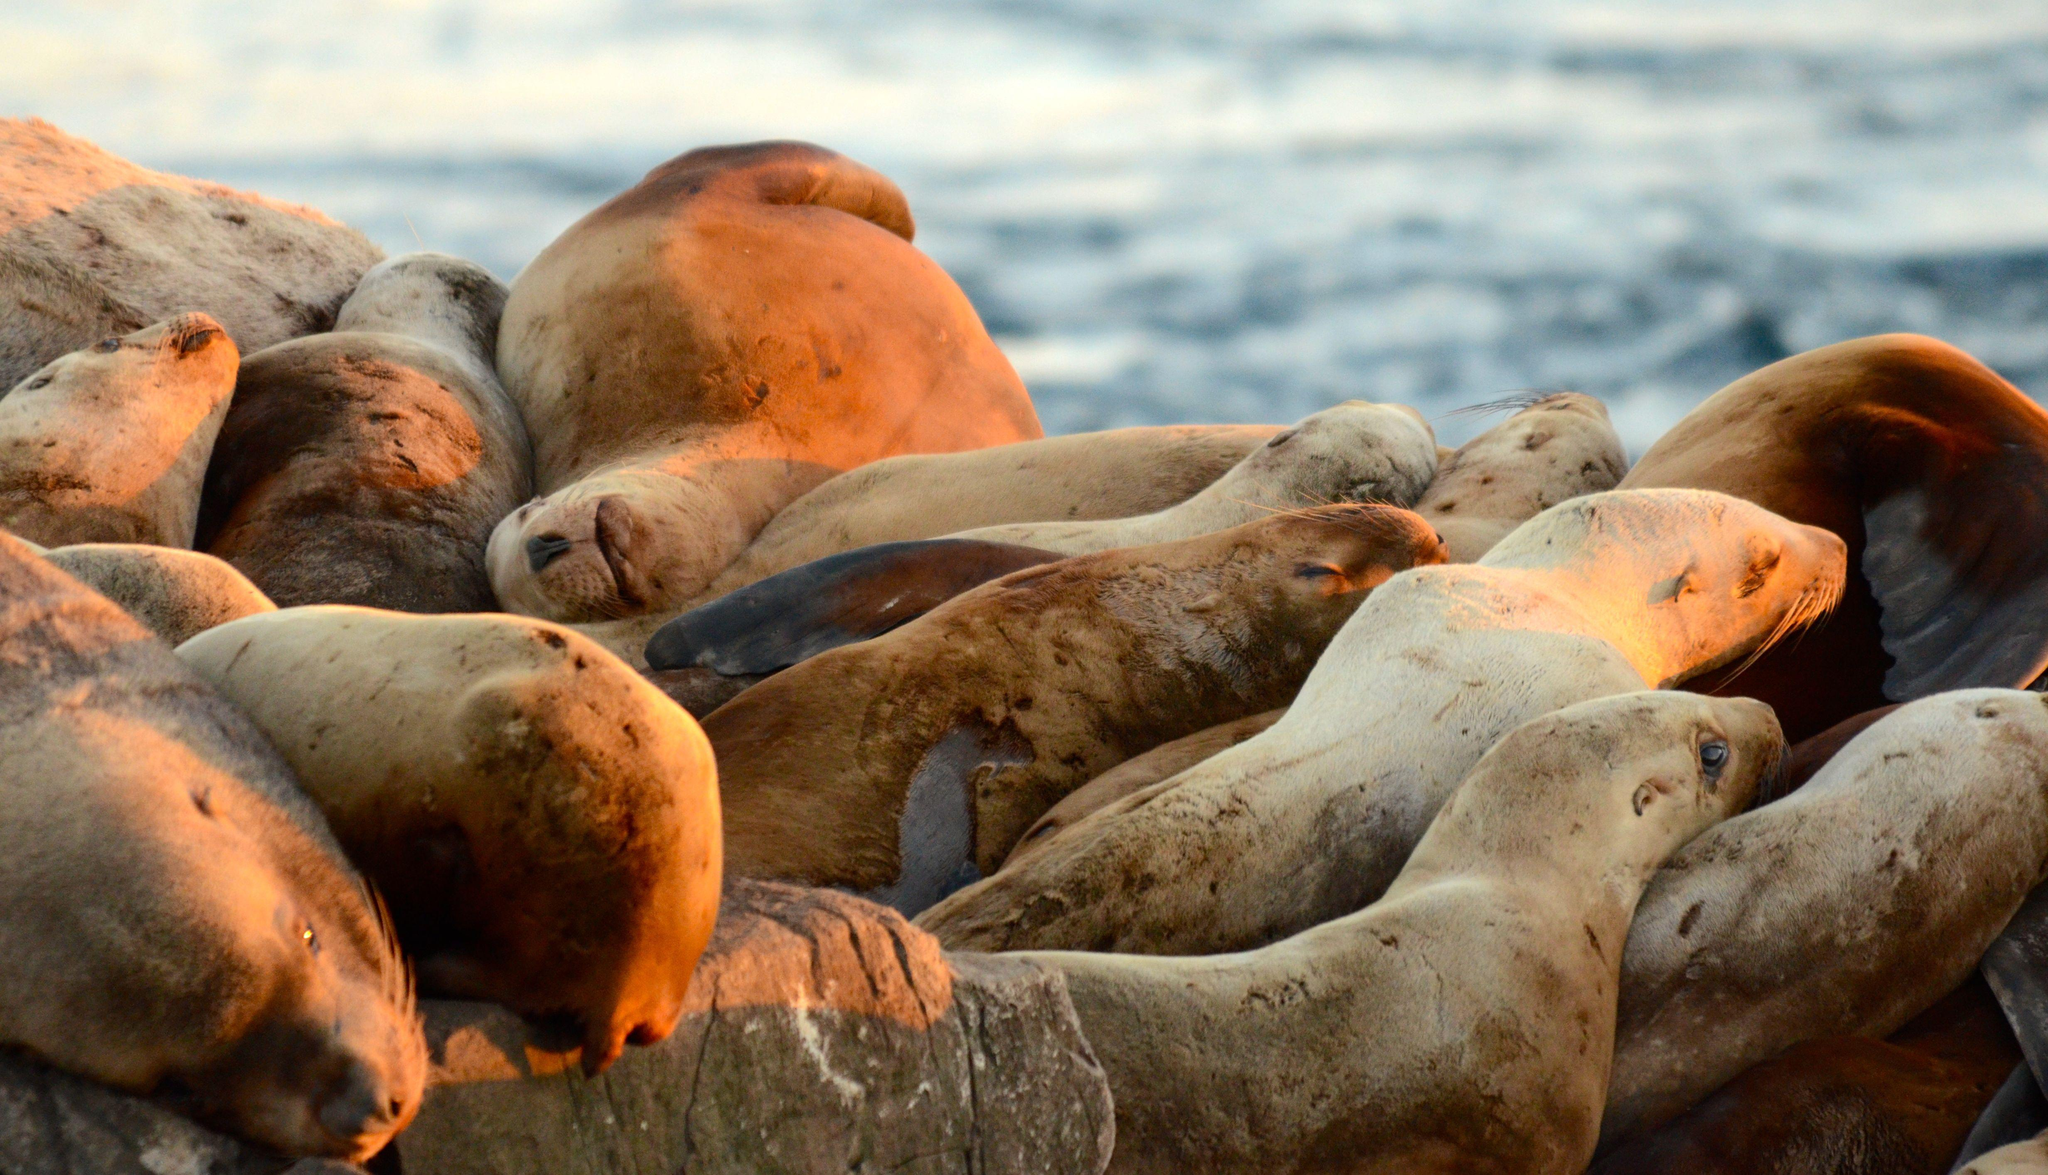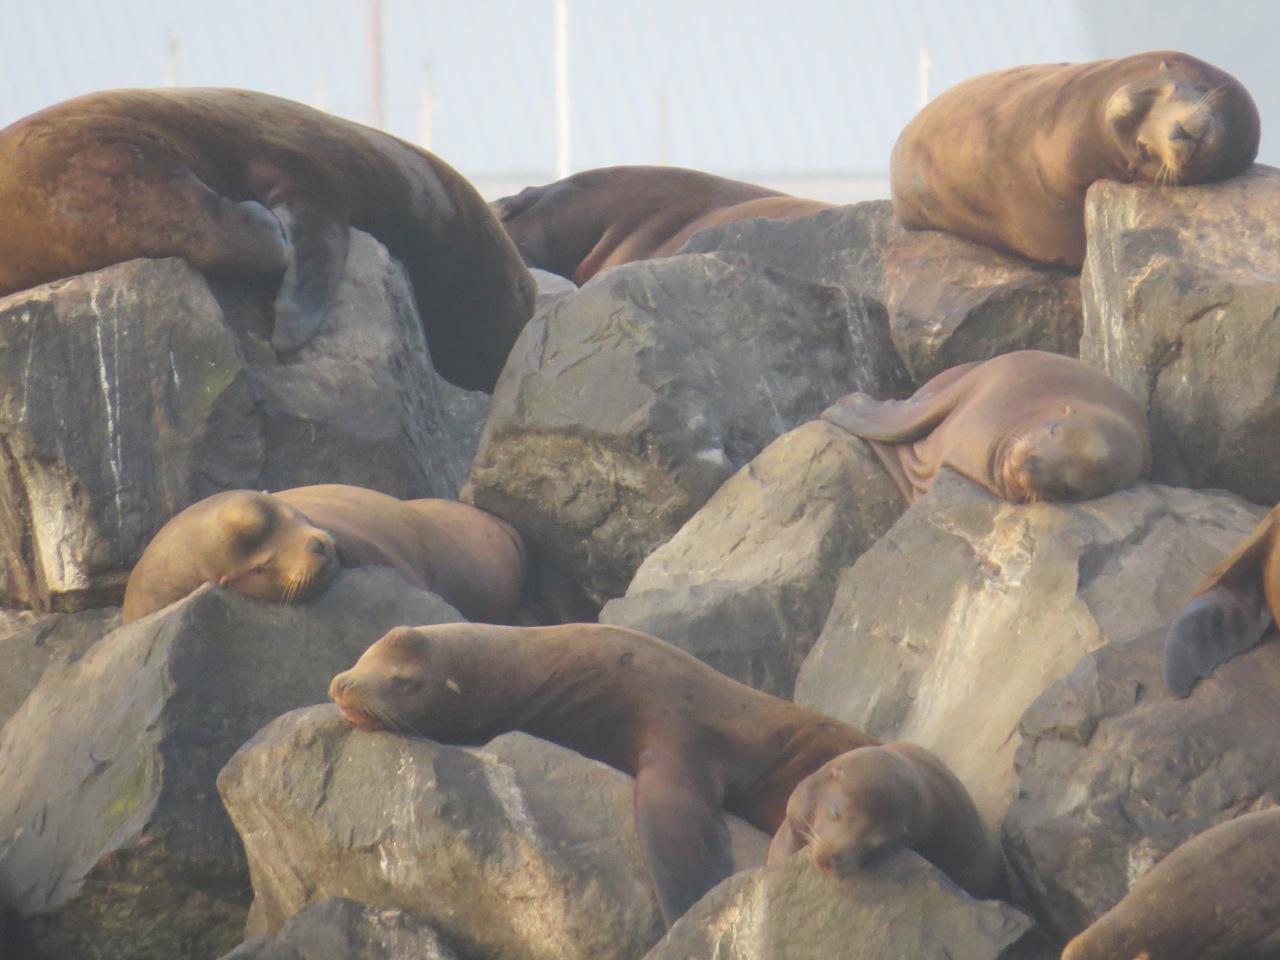The first image is the image on the left, the second image is the image on the right. For the images displayed, is the sentence "The left hand image shows less than four seals laying on the ground." factually correct? Answer yes or no. No. The first image is the image on the left, the second image is the image on the right. Considering the images on both sides, is "One image shows no more than three seals in the foreground, and the other shows seals piled on top of each other." valid? Answer yes or no. No. 